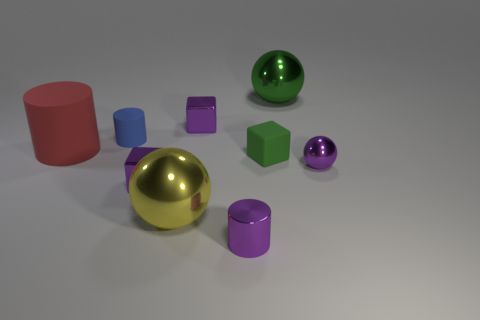There is a purple object that is the same shape as the blue thing; what size is it?
Ensure brevity in your answer.  Small. There is a green object that is in front of the small purple metallic thing that is behind the tiny green rubber thing; what number of big balls are left of it?
Your answer should be very brief. 1. How many balls are small blue metallic things or yellow metal things?
Keep it short and to the point. 1. The metal object on the left side of the large metallic sphere in front of the big shiny ball behind the small purple ball is what color?
Ensure brevity in your answer.  Purple. What number of other objects are there of the same size as the green shiny ball?
Provide a short and direct response. 2. Is there anything else that has the same shape as the tiny blue rubber thing?
Give a very brief answer. Yes. What color is the small rubber thing that is the same shape as the big matte thing?
Provide a short and direct response. Blue. There is a small cylinder that is the same material as the tiny green cube; what color is it?
Make the answer very short. Blue. Are there an equal number of tiny balls behind the small blue cylinder and green balls?
Provide a short and direct response. No. There is a matte object on the right side of the yellow shiny object; is its size the same as the small sphere?
Provide a short and direct response. Yes. 